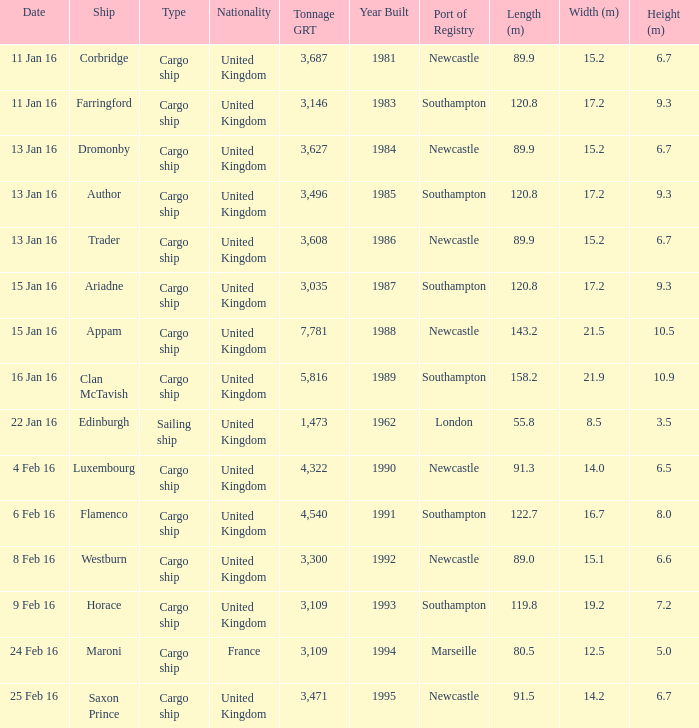What is the most tonnage grt of any ship sunk or captured on 16 jan 16? 5816.0. 